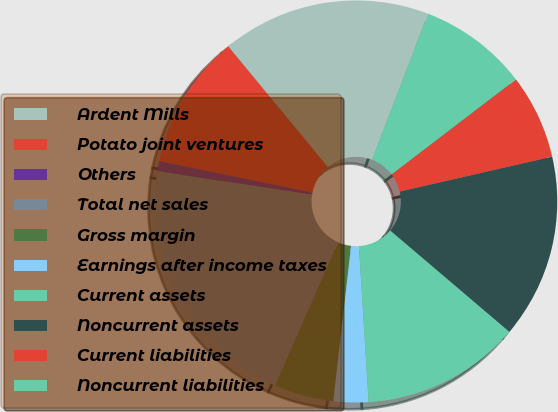<chart> <loc_0><loc_0><loc_500><loc_500><pie_chart><fcel>Ardent Mills<fcel>Potato joint ventures<fcel>Others<fcel>Total net sales<fcel>Gross margin<fcel>Earnings after income taxes<fcel>Current assets<fcel>Noncurrent assets<fcel>Current liabilities<fcel>Noncurrent liabilities<nl><fcel>16.8%<fcel>10.8%<fcel>0.8%<fcel>20.8%<fcel>4.8%<fcel>2.8%<fcel>12.8%<fcel>14.8%<fcel>6.8%<fcel>8.8%<nl></chart> 